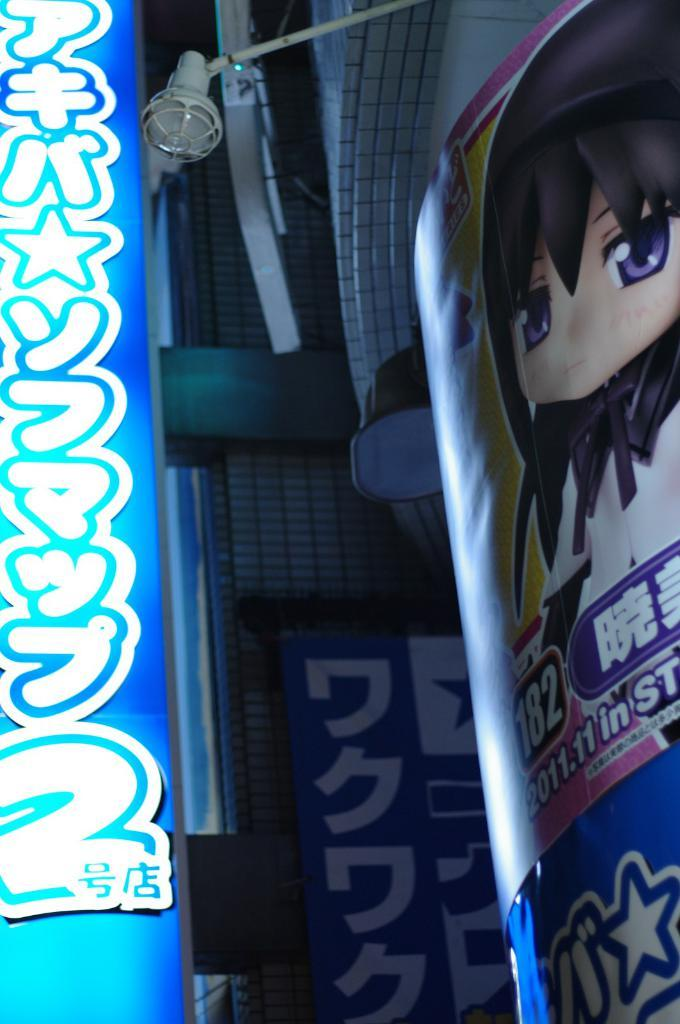What is the main object in the image? There is a light board in the image. What can be seen on the light board? Something is written on the light board. What other object is present in the image? There is a poster with a cartoon image in the image. How does the light board connect to the skate in the image? There is no skate present in the image, so it cannot be connected to the light board. 